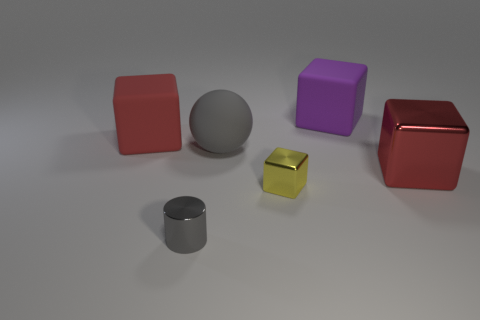What materials are the cubes made of in this image? The cubes in this image appear to have different finishes: one is matte red, another is glossy red, and the third one has a matte yellow finish. 